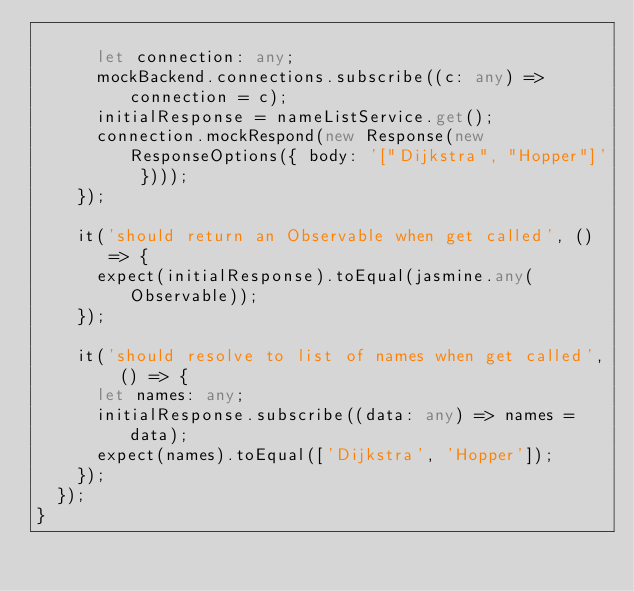Convert code to text. <code><loc_0><loc_0><loc_500><loc_500><_TypeScript_>
      let connection: any;
      mockBackend.connections.subscribe((c: any) => connection = c);
      initialResponse = nameListService.get();
      connection.mockRespond(new Response(new ResponseOptions({ body: '["Dijkstra", "Hopper"]' })));
    });

    it('should return an Observable when get called', () => {
      expect(initialResponse).toEqual(jasmine.any(Observable));
    });

    it('should resolve to list of names when get called', () => {
      let names: any;
      initialResponse.subscribe((data: any) => names = data);
      expect(names).toEqual(['Dijkstra', 'Hopper']);
    });
  });
}
</code> 